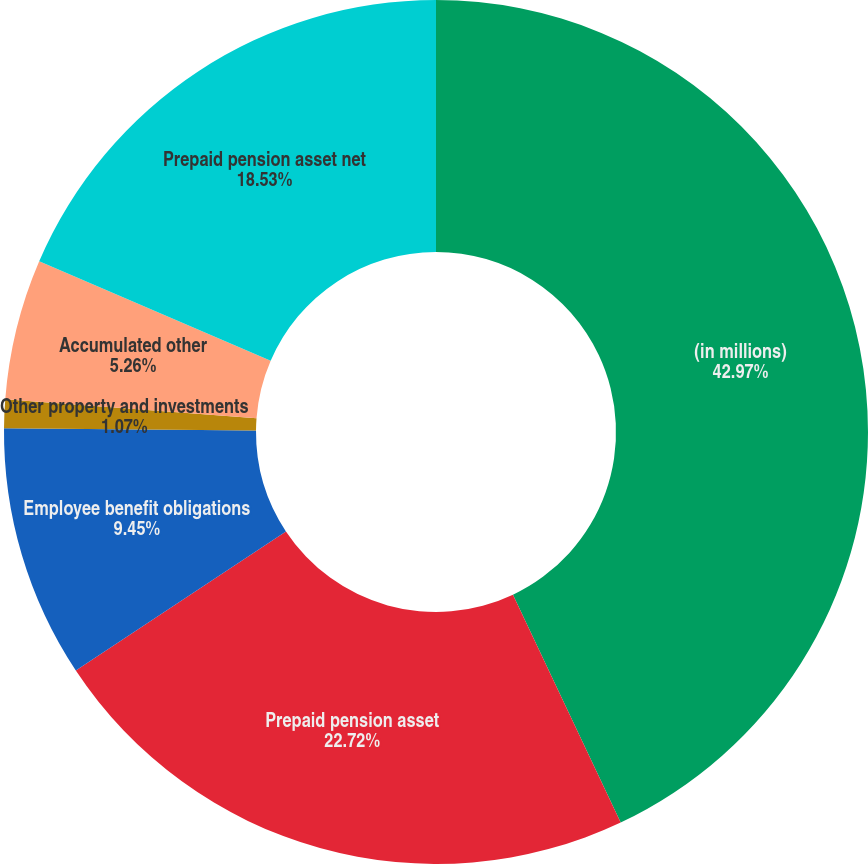<chart> <loc_0><loc_0><loc_500><loc_500><pie_chart><fcel>(in millions)<fcel>Prepaid pension asset<fcel>Employee benefit obligations<fcel>Other property and investments<fcel>Accumulated other<fcel>Prepaid pension asset net<nl><fcel>42.97%<fcel>22.72%<fcel>9.45%<fcel>1.07%<fcel>5.26%<fcel>18.53%<nl></chart> 